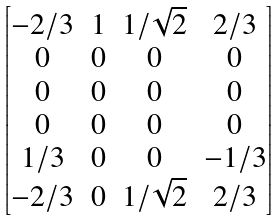<formula> <loc_0><loc_0><loc_500><loc_500>\begin{bmatrix} - 2 / 3 & 1 & 1 / \sqrt { 2 } & 2 / 3 \\ 0 & 0 & 0 & 0 \\ 0 & 0 & 0 & 0 \\ 0 & 0 & 0 & 0 \\ 1 / 3 & 0 & 0 & - 1 / 3 \\ - 2 / 3 & 0 & 1 / \sqrt { 2 } & 2 / 3 \end{bmatrix}</formula> 